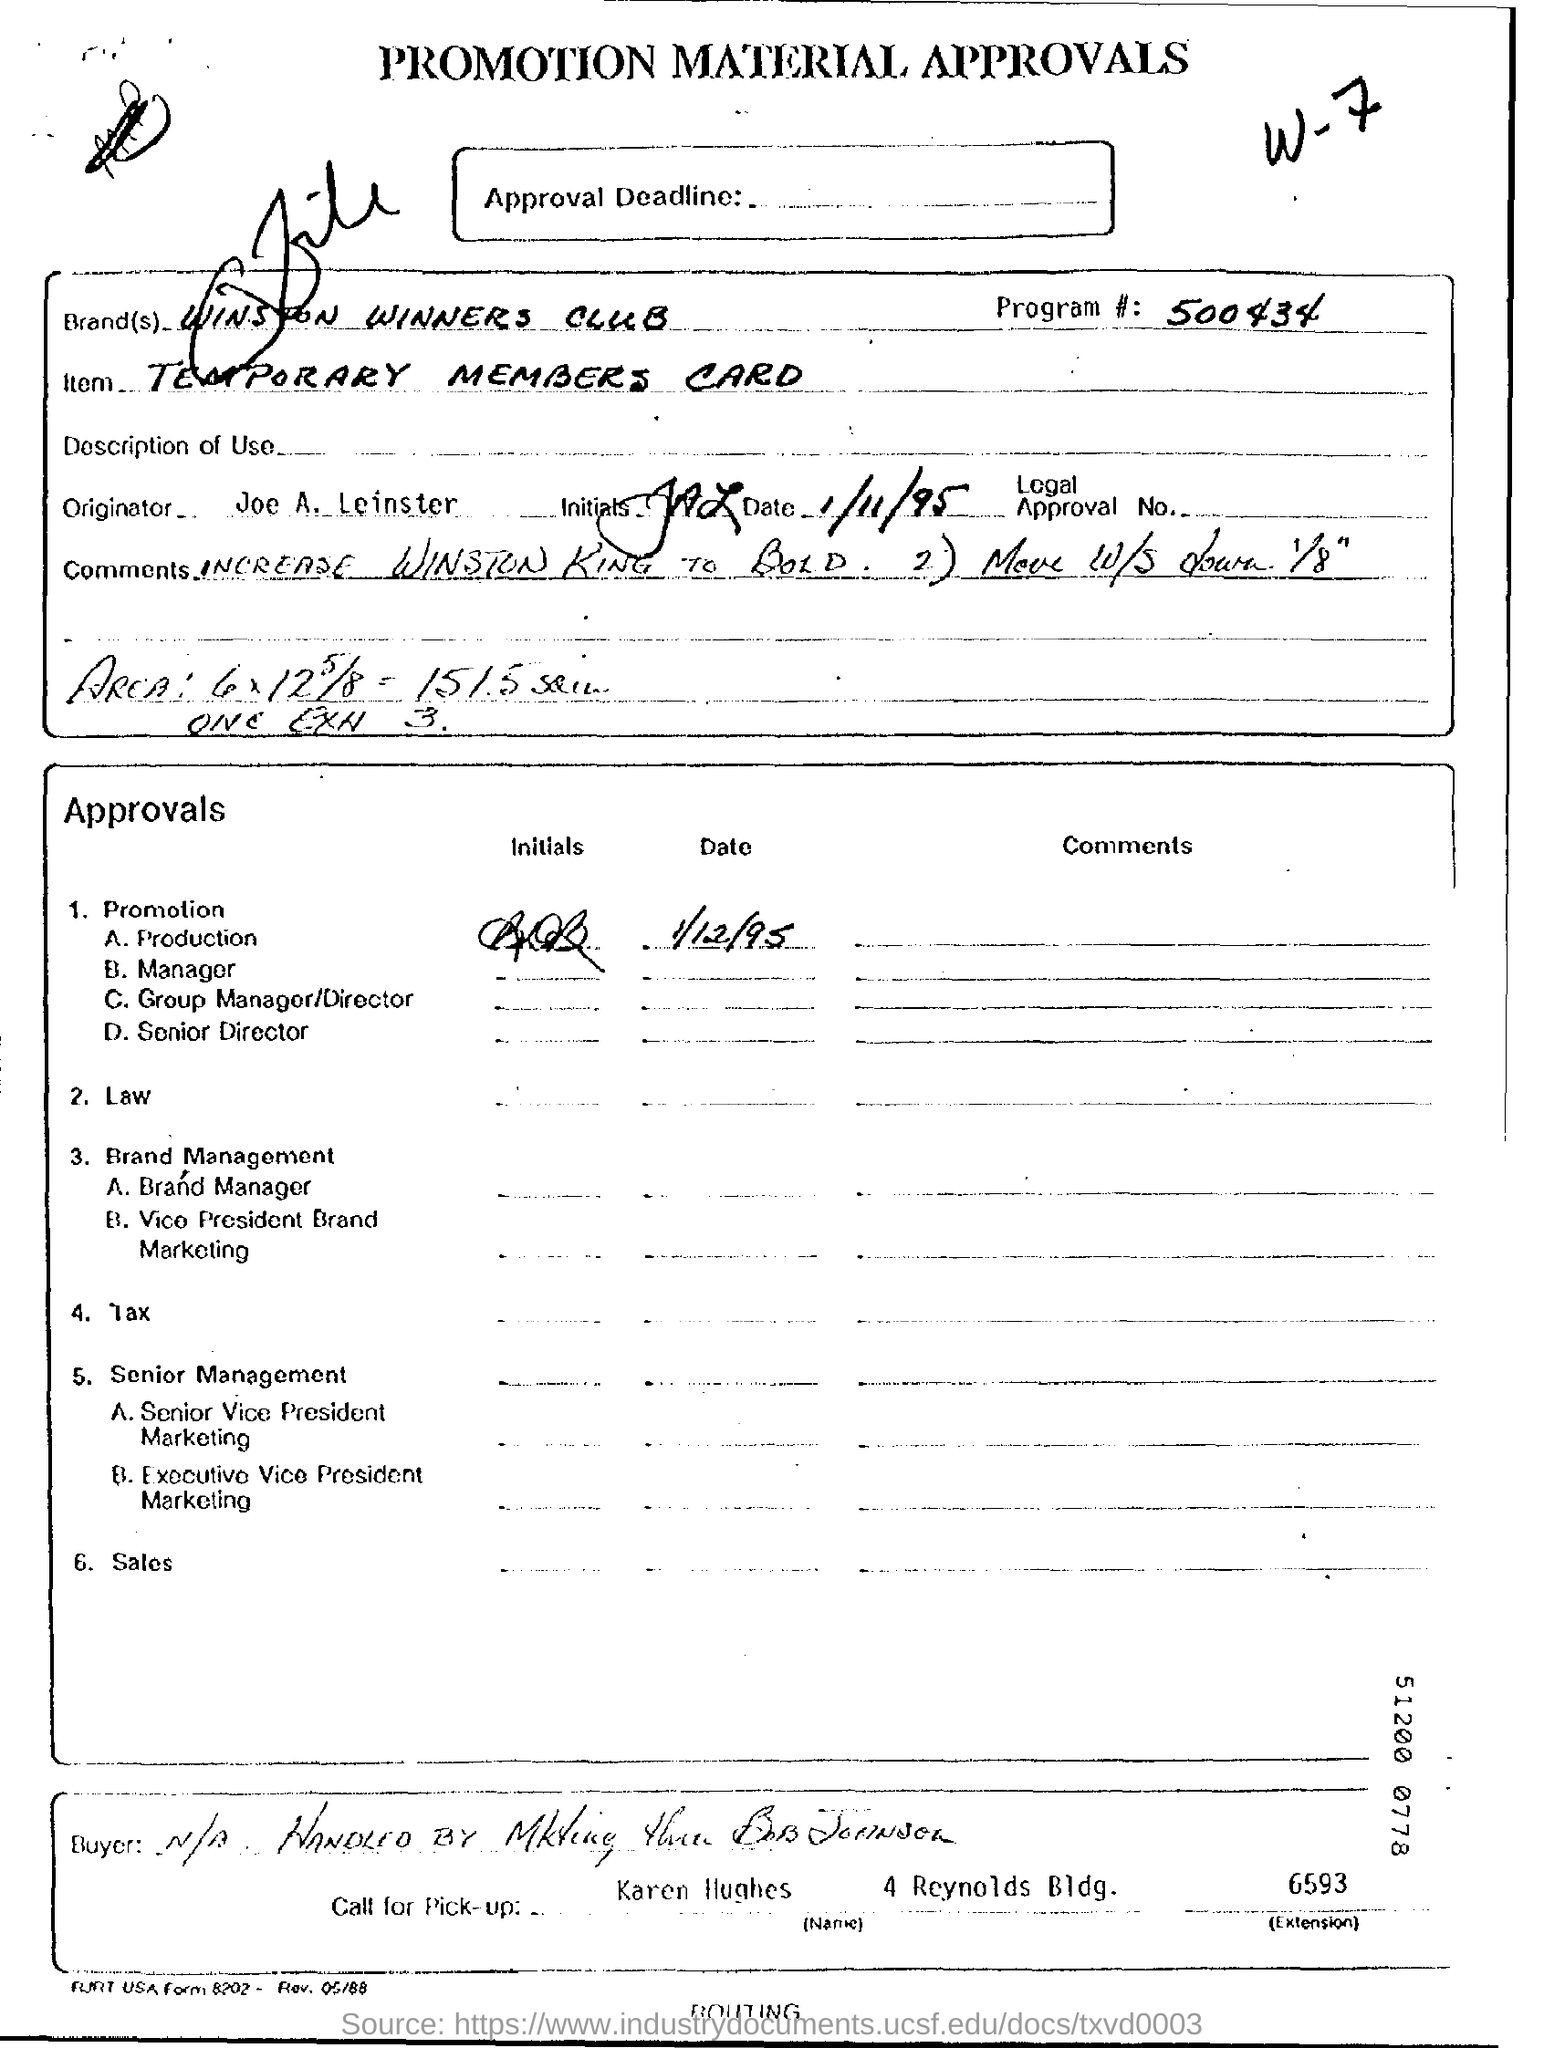Outline some significant characteristics in this image. The extension number for Karen Hughes is 6593. Joe A. Leinster is the originator. The program number is 500434. The temporary members card is the item being referred to. The title of the document is "Promotion Material Approvals. 